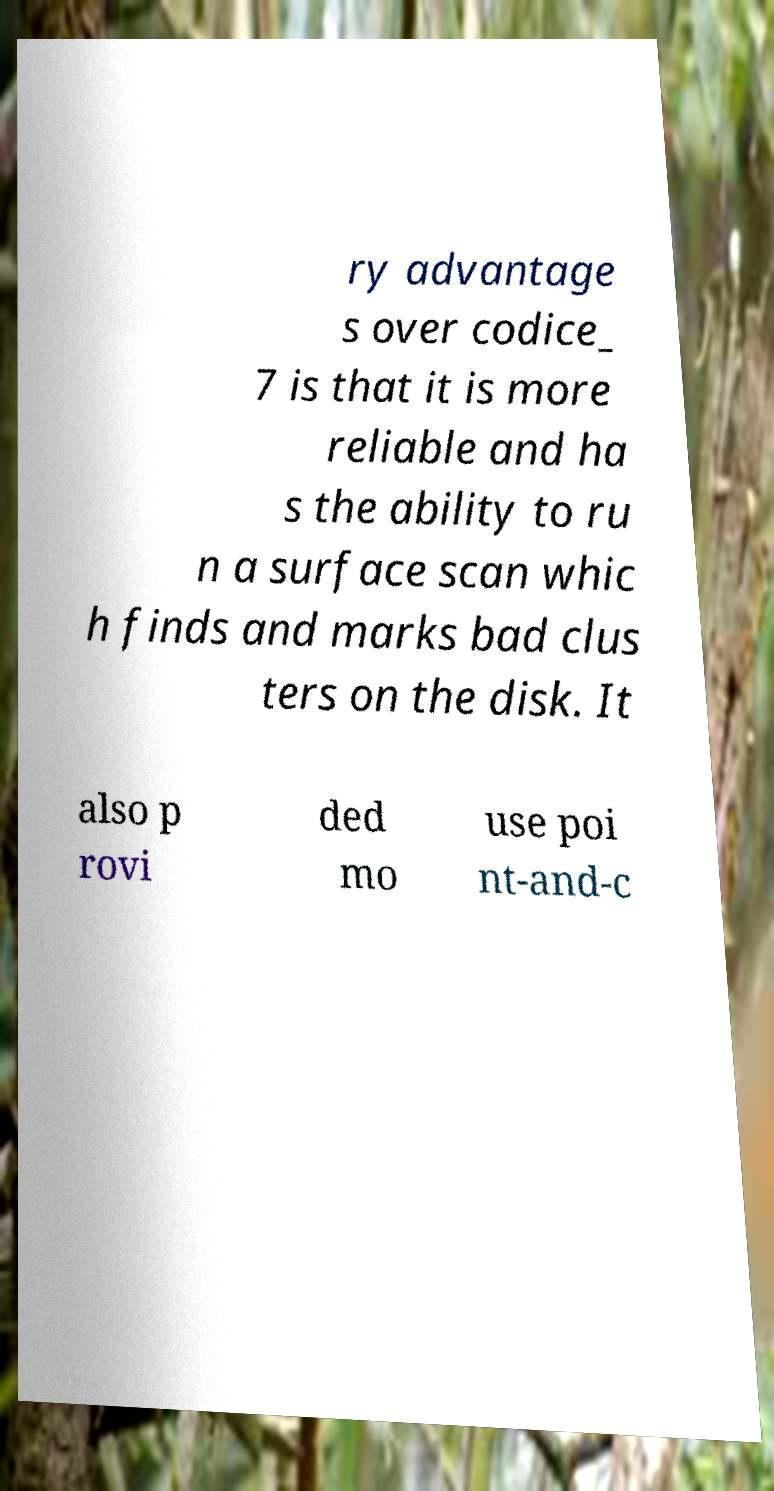What messages or text are displayed in this image? I need them in a readable, typed format. ry advantage s over codice_ 7 is that it is more reliable and ha s the ability to ru n a surface scan whic h finds and marks bad clus ters on the disk. It also p rovi ded mo use poi nt-and-c 